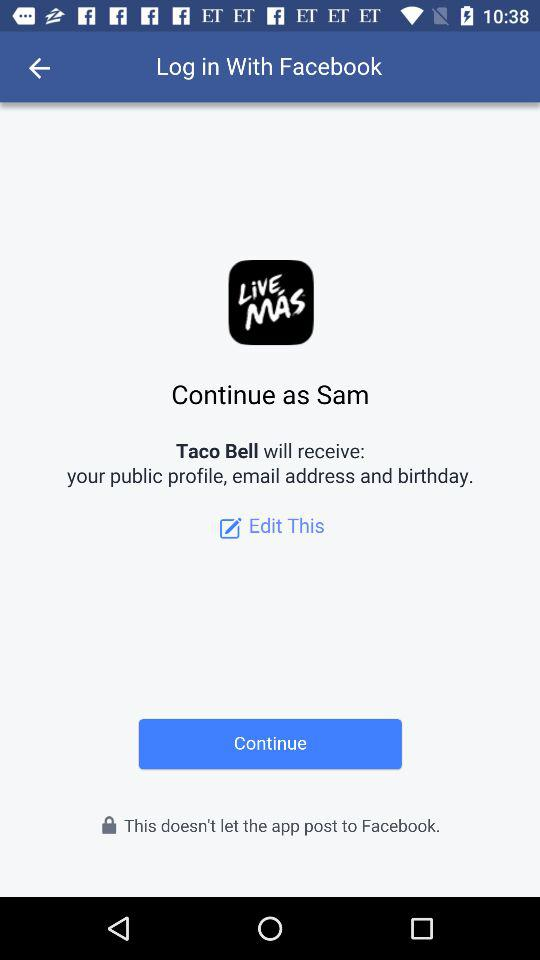What application receives the user's email address and birthday? The application that will receive the user's email address and birthday is "Taco Bell". 